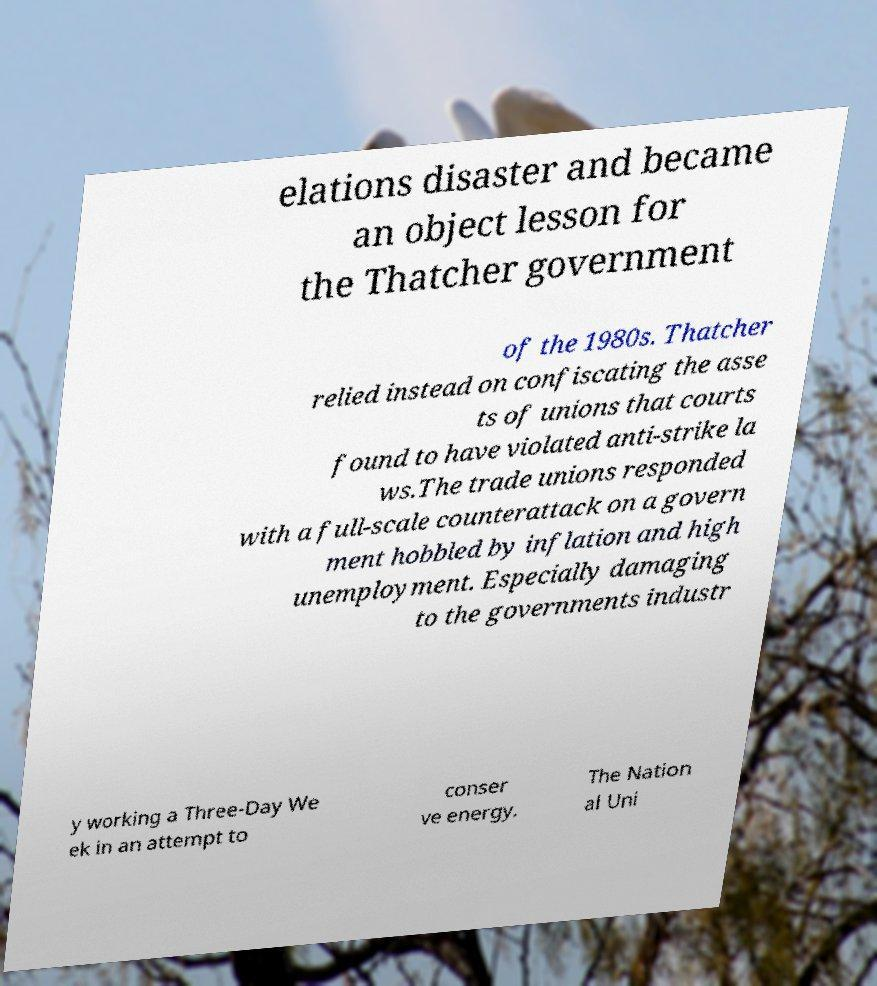Could you extract and type out the text from this image? elations disaster and became an object lesson for the Thatcher government of the 1980s. Thatcher relied instead on confiscating the asse ts of unions that courts found to have violated anti-strike la ws.The trade unions responded with a full-scale counterattack on a govern ment hobbled by inflation and high unemployment. Especially damaging to the governments industr y working a Three-Day We ek in an attempt to conser ve energy. The Nation al Uni 